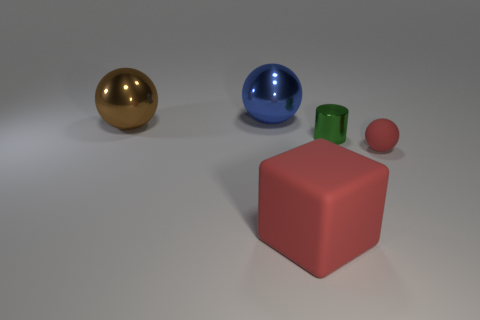Do the tiny cylinder that is right of the red matte block and the big ball right of the brown metal sphere have the same material?
Keep it short and to the point. Yes. Are there any brown cubes that have the same size as the cylinder?
Make the answer very short. No. What is the size of the red thing to the right of the large object in front of the green object?
Offer a very short reply. Small. What number of other large rubber things have the same color as the big rubber object?
Keep it short and to the point. 0. What shape is the tiny thing behind the ball that is on the right side of the tiny green cylinder?
Give a very brief answer. Cylinder. What number of other green cylinders have the same material as the cylinder?
Provide a succinct answer. 0. What is the material of the object right of the tiny metal object?
Keep it short and to the point. Rubber. There is a tiny thing that is to the left of the red matte object that is on the right side of the matte object that is left of the red sphere; what is its shape?
Your answer should be very brief. Cylinder. There is a ball that is right of the big rubber thing; does it have the same color as the large object in front of the small green metallic cylinder?
Your response must be concise. Yes. Are there fewer small green things that are behind the large blue metal thing than red rubber objects behind the cube?
Keep it short and to the point. Yes. 